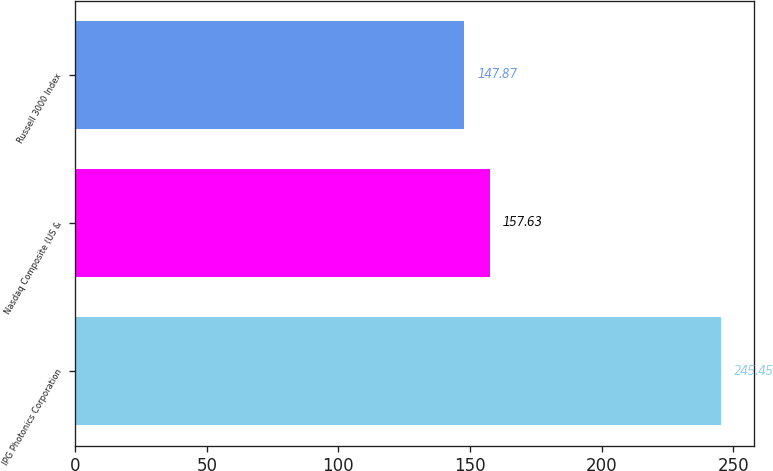Convert chart to OTSL. <chart><loc_0><loc_0><loc_500><loc_500><bar_chart><fcel>IPG Photonics Corporation<fcel>Nasdaq Composite (US &<fcel>Russell 3000 Index<nl><fcel>245.45<fcel>157.63<fcel>147.87<nl></chart> 